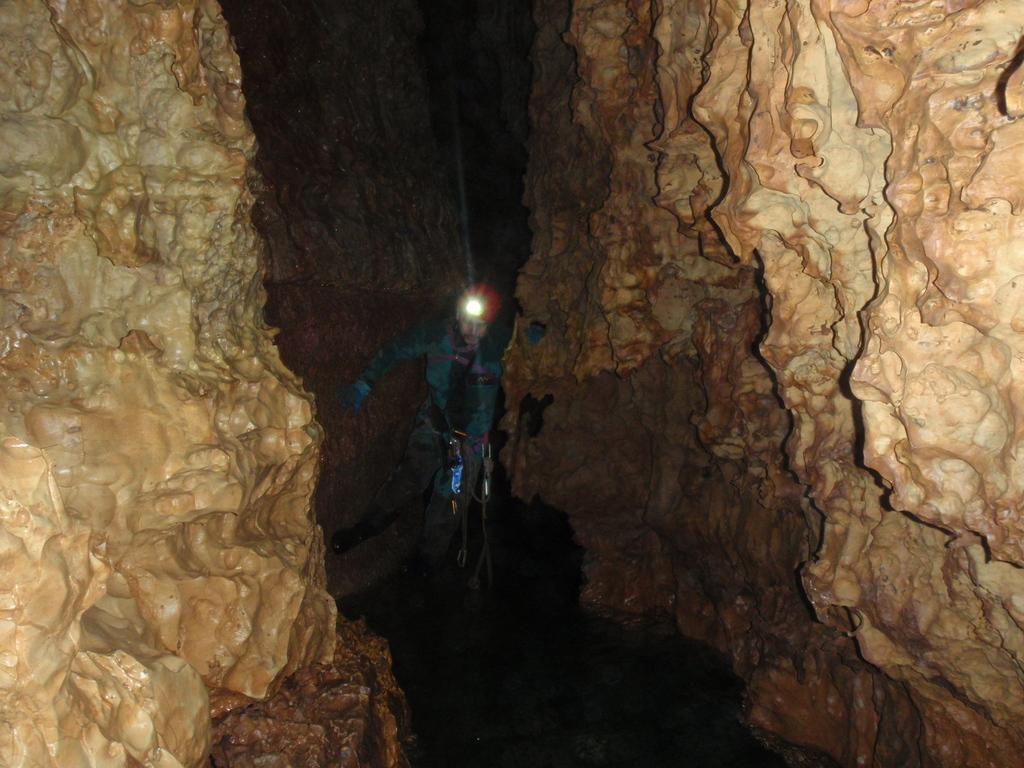Where is the setting of the image? The image is inside a cave. Can you describe the person in the image? The person in the image is wearing a helmet. What is the purpose of the light on the helmet? The light on the helmet helps the person see in the dark cave. What is the person doing in the image? The person is walking between the caves. Where is the faucet located in the image? There is no faucet present in the image; it is set inside a cave. What type of ground can be seen in the image? The ground in the image is not specified, as the focus is on the person and their surroundings in the cave. 